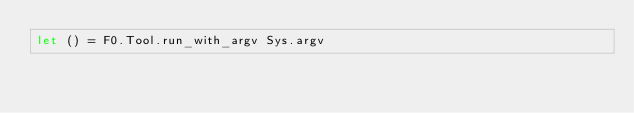<code> <loc_0><loc_0><loc_500><loc_500><_OCaml_>let () = F0.Tool.run_with_argv Sys.argv
</code> 